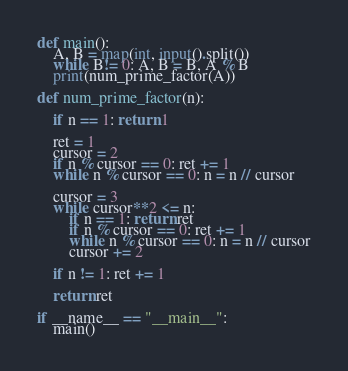<code> <loc_0><loc_0><loc_500><loc_500><_Python_>def main():
    A, B = map(int, input().split())
    while B!= 0: A, B = B, A % B 
    print(num_prime_factor(A))

def num_prime_factor(n):
    
    if n == 1: return 1
    
    ret = 1
    cursor = 2
    if n % cursor == 0: ret += 1
    while n % cursor == 0: n = n // cursor
    
    cursor = 3
    while cursor**2 <= n:
        if n == 1: return ret
        if n % cursor == 0: ret += 1
        while n % cursor == 0: n = n // cursor
        cursor += 2

    if n != 1: ret += 1
        
    return ret

if __name__ == "__main__":
    main()</code> 